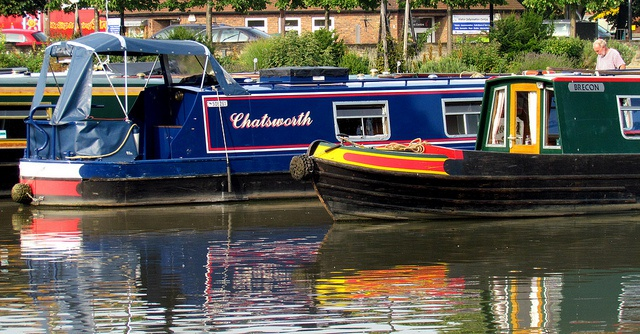Describe the objects in this image and their specific colors. I can see boat in black, navy, white, and gray tones, boat in black, gray, and white tones, car in black, lightgray, salmon, and red tones, people in black, lightgray, salmon, olive, and tan tones, and car in black, darkgray, lightgray, and gray tones in this image. 